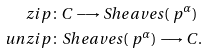<formula> <loc_0><loc_0><loc_500><loc_500>\ z i p & \colon C \longrightarrow S h e a v e s ( \ p ^ { \alpha } ) \\ \ u n z i p & \colon S h e a v e s ( \ p ^ { \alpha } ) \longrightarrow C .</formula> 